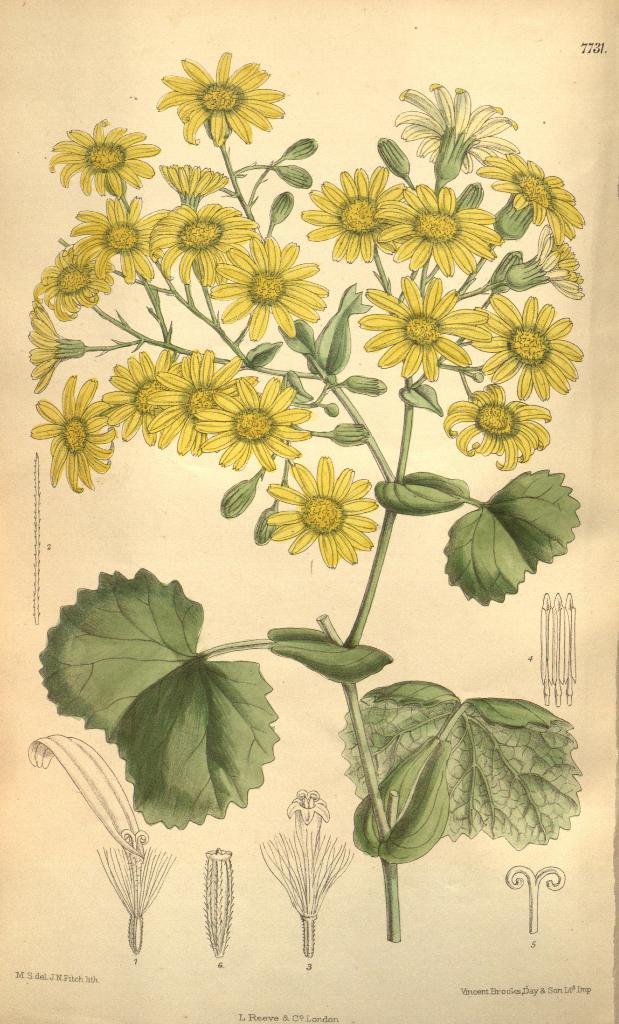Describe this image in one or two sentences. This image contains a picture of a painting of a plant having few flowers and leaves. Bottom of image there is some drawings and some text. 